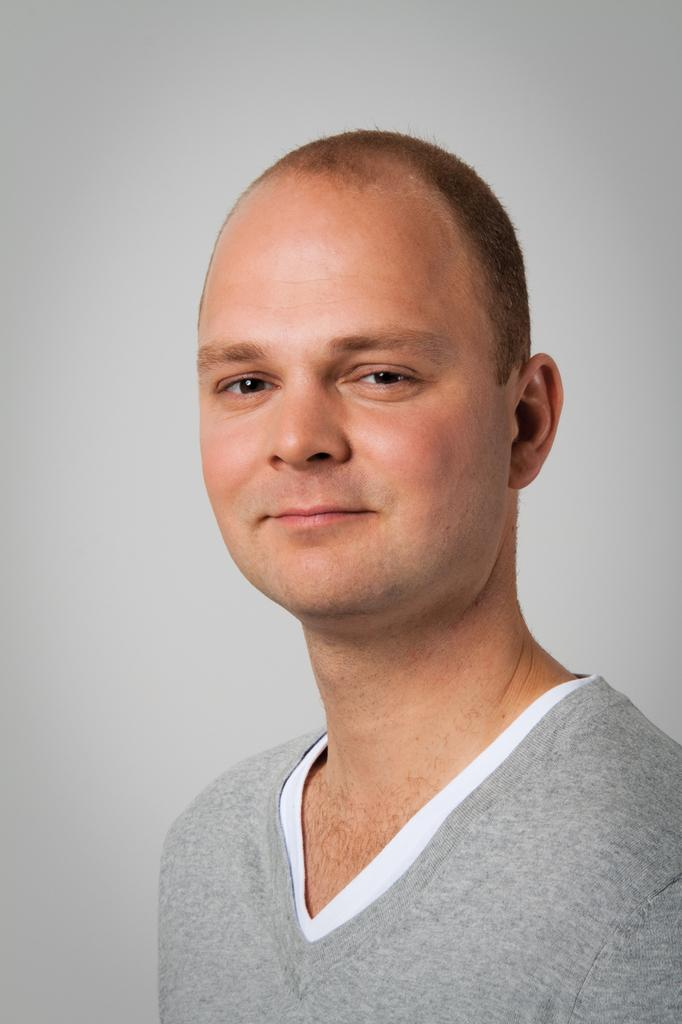What is present in the image? There is a person in the image. How is the person's expression in the image? The person is smiling. What can be seen in the background of the image? There is a wall in the background of the image. What type of seed is the person holding in the image? There is no seed present in the image; the person is not holding anything. 